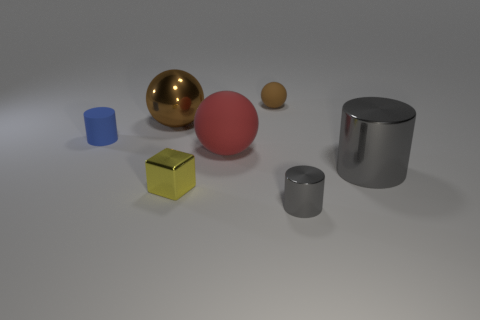Subtract all big balls. How many balls are left? 1 Subtract 1 cubes. How many cubes are left? 0 Subtract all blue cylinders. How many cylinders are left? 2 Subtract all cubes. How many objects are left? 6 Subtract all blue spheres. Subtract all cyan blocks. How many spheres are left? 3 Subtract all cyan cylinders. How many purple cubes are left? 0 Subtract all large metal spheres. Subtract all cubes. How many objects are left? 5 Add 7 rubber things. How many rubber things are left? 10 Add 2 blue cylinders. How many blue cylinders exist? 3 Add 3 yellow matte blocks. How many objects exist? 10 